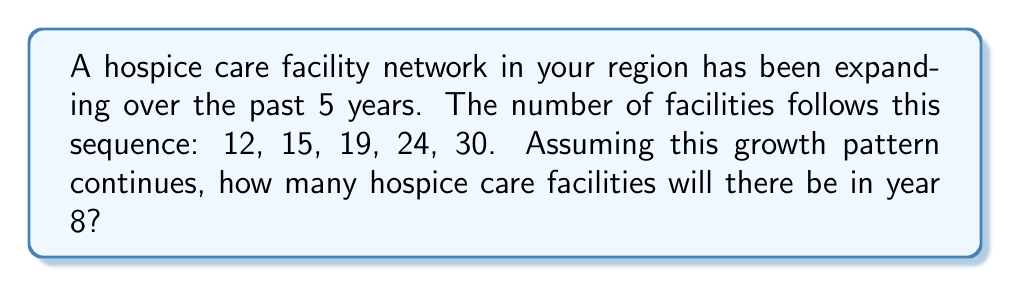What is the answer to this math problem? To solve this problem, we need to identify the pattern in the sequence and extend it to year 8. Let's analyze the growth:

1. From year 1 to 2: 15 - 12 = 3
2. From year 2 to 3: 19 - 15 = 4
3. From year 3 to 4: 24 - 19 = 5
4. From year 4 to 5: 30 - 24 = 6

We can see that the difference between consecutive terms is increasing by 1 each year. This forms an arithmetic sequence of second order.

Let's continue the pattern:
5. Year 6: 30 + 7 = 37
6. Year 7: 37 + 8 = 45
7. Year 8: 45 + 9 = 54

The general formula for this sequence is:

$$a_n = \frac{n(n+1)}{2} + 11$$

Where $a_n$ is the number of facilities in year $n$.

For year 8:

$$a_8 = \frac{8(8+1)}{2} + 11 = \frac{8(9)}{2} + 11 = 36 + 11 = 47 + 7 = 54$$

This confirms our step-by-step calculation.
Answer: 54 facilities 